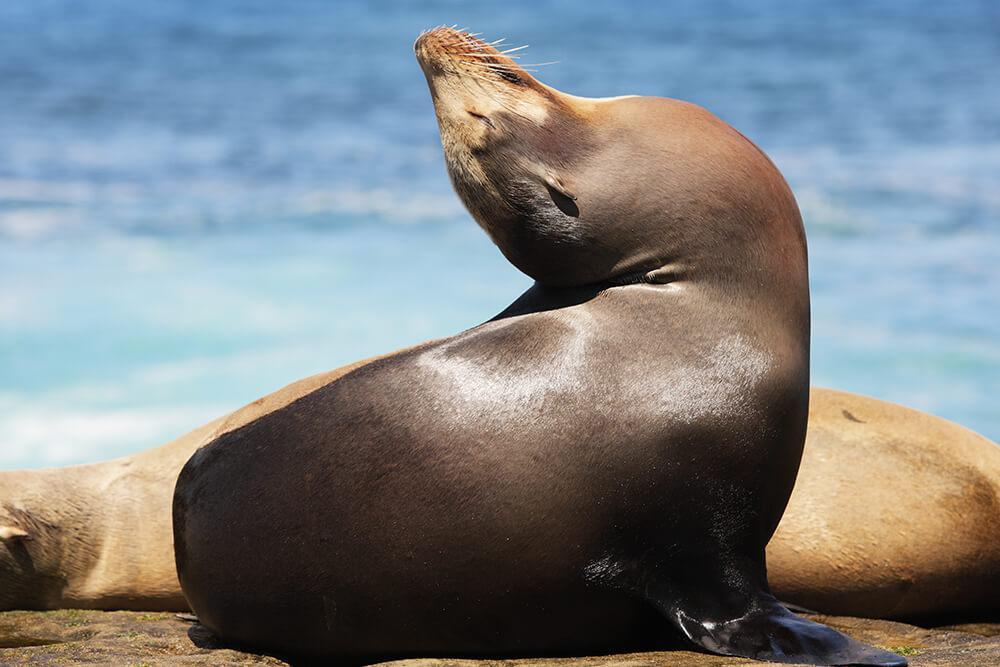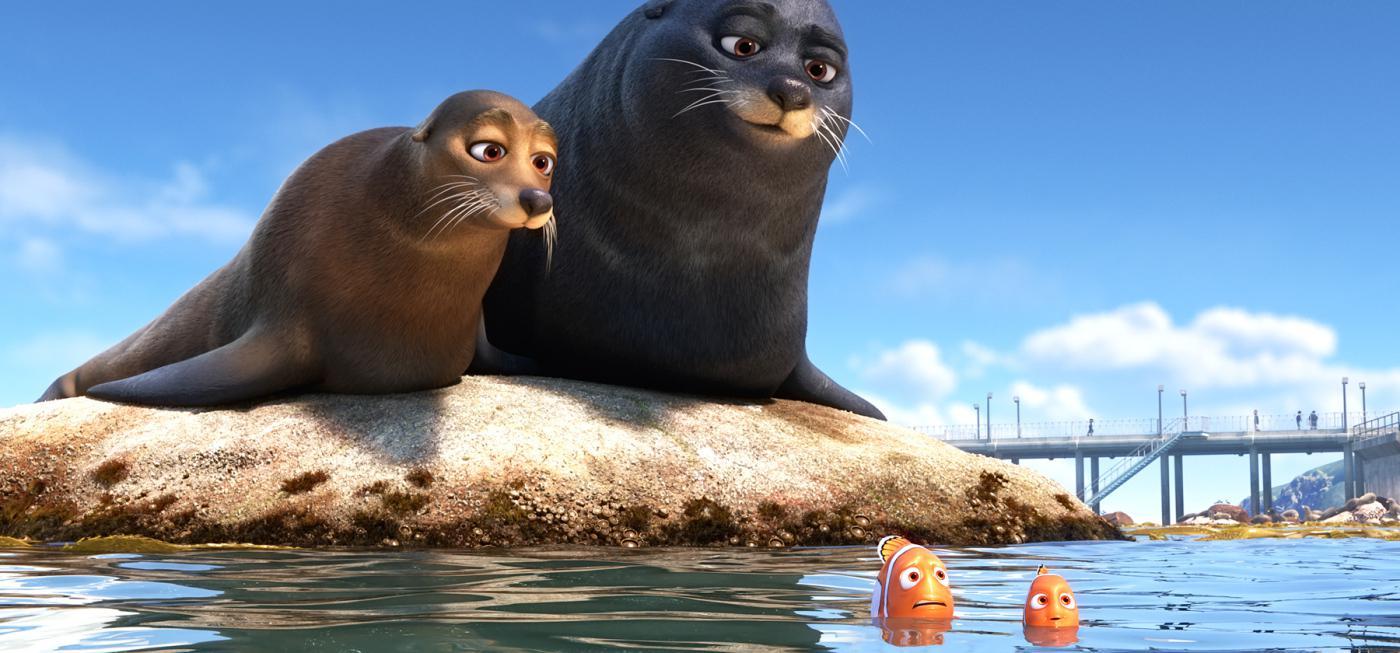The first image is the image on the left, the second image is the image on the right. Analyze the images presented: Is the assertion "there are two seals in the image on the right." valid? Answer yes or no. Yes. The first image is the image on the left, the second image is the image on the right. Evaluate the accuracy of this statement regarding the images: "There are two seals". Is it true? Answer yes or no. No. 